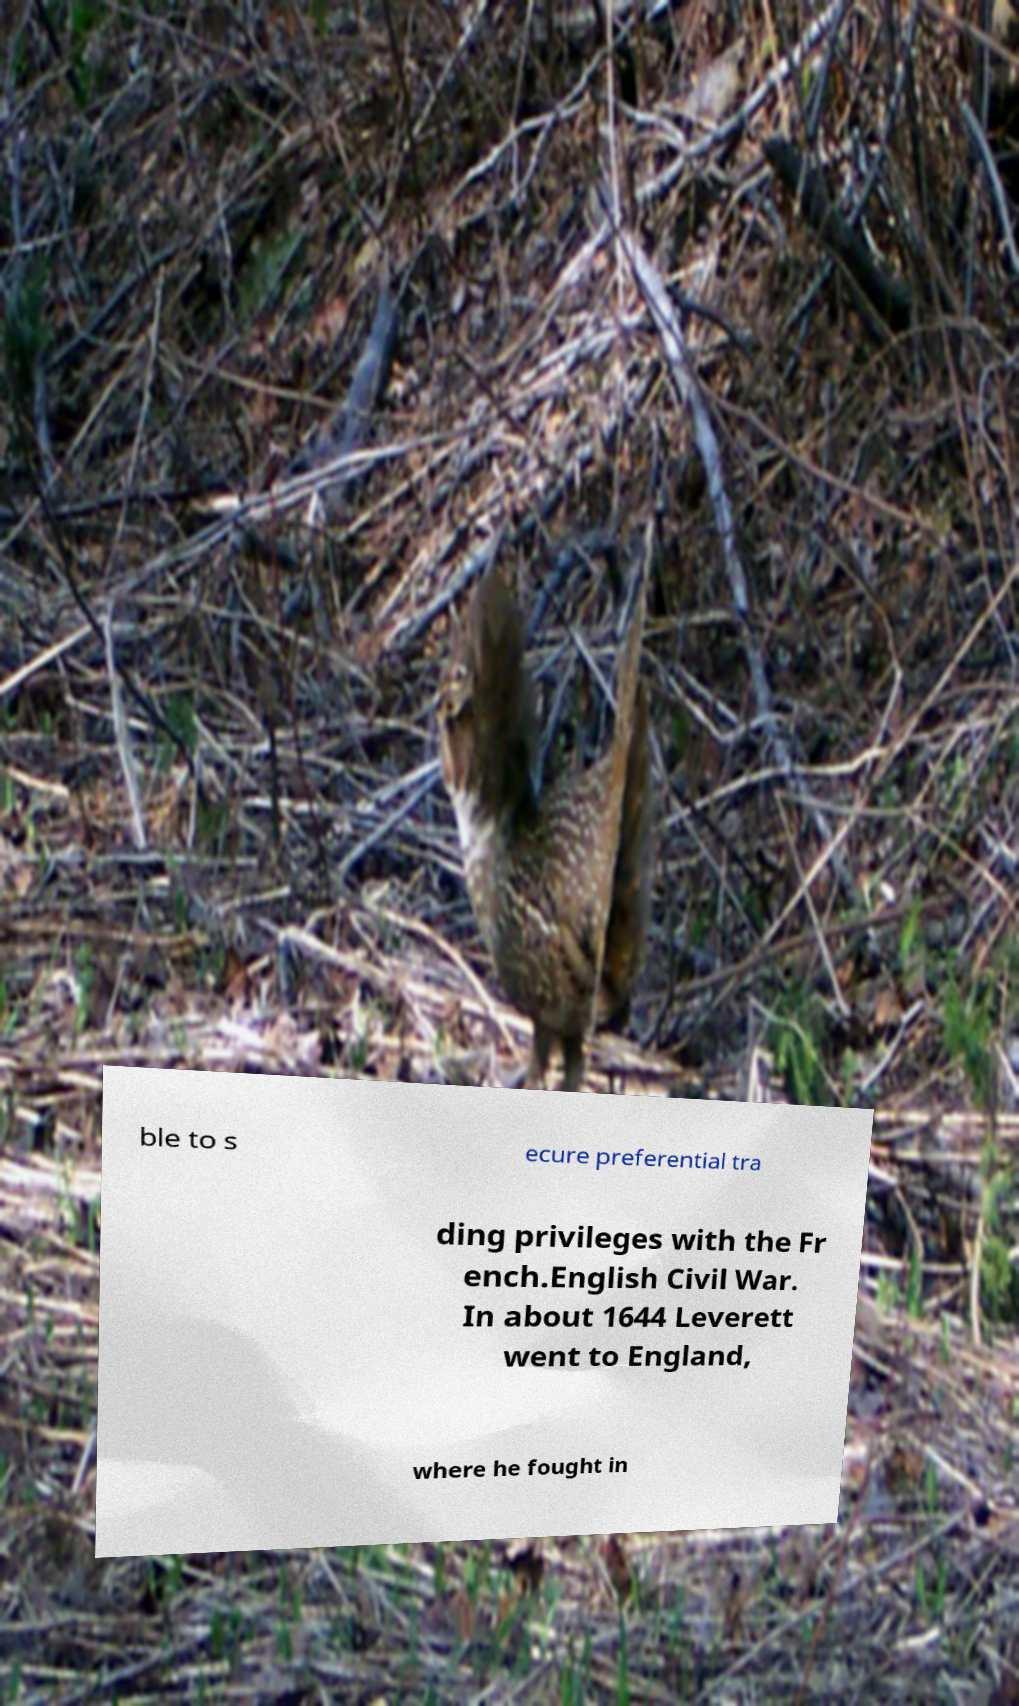Can you accurately transcribe the text from the provided image for me? ble to s ecure preferential tra ding privileges with the Fr ench.English Civil War. In about 1644 Leverett went to England, where he fought in 